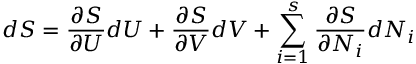<formula> <loc_0><loc_0><loc_500><loc_500>d S = { \frac { \partial S } { \partial U } } d U + { \frac { \partial S } { \partial V } } d V + \sum _ { i = 1 } ^ { s } { \frac { \partial S } { \partial N _ { i } } } d N _ { i }</formula> 